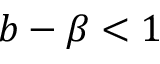Convert formula to latex. <formula><loc_0><loc_0><loc_500><loc_500>b - \beta < 1</formula> 